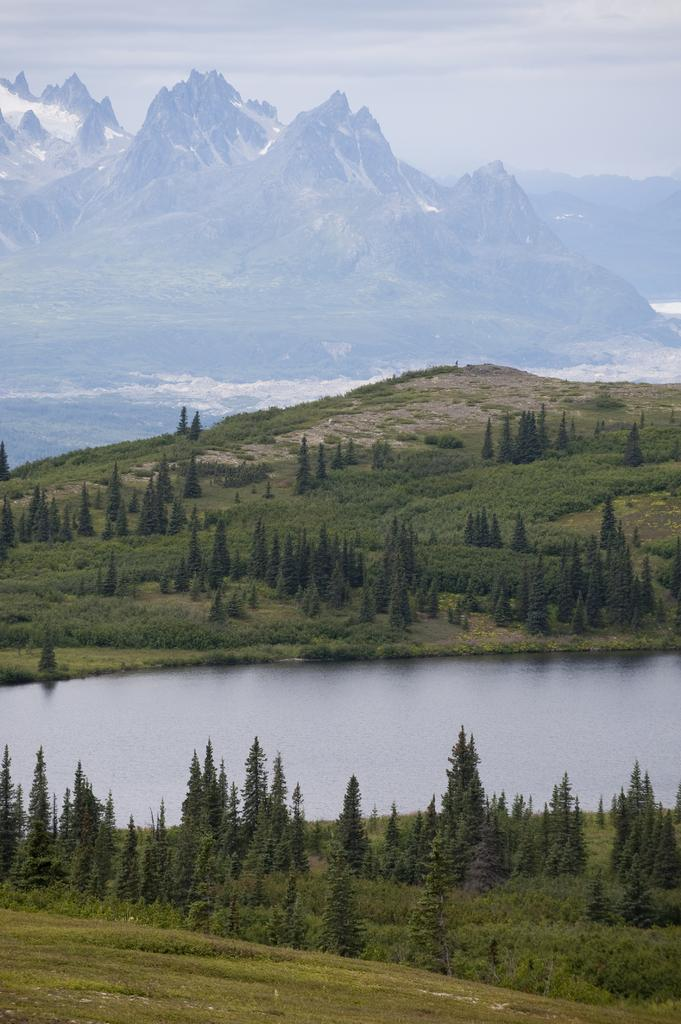What is the main feature in the center of the image? There is a lake in the center of the image. What type of vegetation is at the bottom of the image? There is grass at the bottom of the image. What can be seen in the background of the image? There are trees and hills in the background of the image. What part of the natural environment is visible in the background of the image? The sky is visible in the background of the image. What type of metal object is attracting the attention of the trees in the image? There is no metal object present in the image, and the trees are not shown to be attracted to any object. 